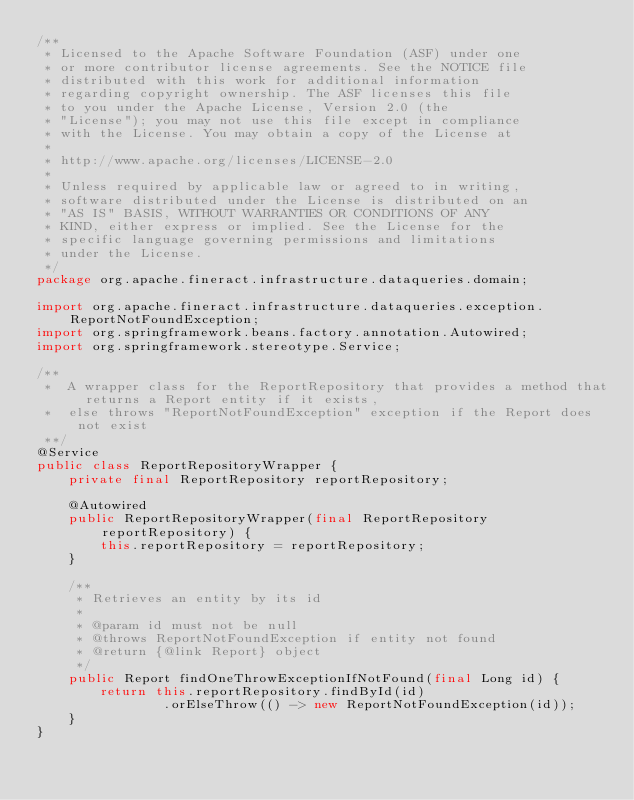<code> <loc_0><loc_0><loc_500><loc_500><_Java_>/**
 * Licensed to the Apache Software Foundation (ASF) under one
 * or more contributor license agreements. See the NOTICE file
 * distributed with this work for additional information
 * regarding copyright ownership. The ASF licenses this file
 * to you under the Apache License, Version 2.0 (the
 * "License"); you may not use this file except in compliance
 * with the License. You may obtain a copy of the License at
 *
 * http://www.apache.org/licenses/LICENSE-2.0
 *
 * Unless required by applicable law or agreed to in writing,
 * software distributed under the License is distributed on an
 * "AS IS" BASIS, WITHOUT WARRANTIES OR CONDITIONS OF ANY
 * KIND, either express or implied. See the License for the
 * specific language governing permissions and limitations
 * under the License.
 */
package org.apache.fineract.infrastructure.dataqueries.domain;

import org.apache.fineract.infrastructure.dataqueries.exception.ReportNotFoundException;
import org.springframework.beans.factory.annotation.Autowired;
import org.springframework.stereotype.Service;

/** 
 *  A wrapper class for the ReportRepository that provides a method that returns a Report entity if it exists, 
 *  else throws "ReportNotFoundException" exception if the Report does not exist
 **/
@Service
public class ReportRepositoryWrapper {
    private final ReportRepository reportRepository;
    
    @Autowired
    public ReportRepositoryWrapper(final ReportRepository reportRepository) {
        this.reportRepository = reportRepository;
    }
    
    /**
     * Retrieves an entity by its id
     * 
     * @param id must not be null
     * @throws ReportNotFoundException if entity not found
     * @return {@link Report} object
     */
    public Report findOneThrowExceptionIfNotFound(final Long id) {
        return this.reportRepository.findById(id)
                .orElseThrow(() -> new ReportNotFoundException(id));
    }
}
</code> 